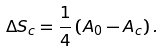<formula> <loc_0><loc_0><loc_500><loc_500>\Delta S _ { c } = \frac { 1 } { 4 } \left ( A _ { 0 } - A _ { c } \right ) .</formula> 